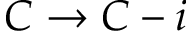Convert formula to latex. <formula><loc_0><loc_0><loc_500><loc_500>C \rightarrow C - i</formula> 